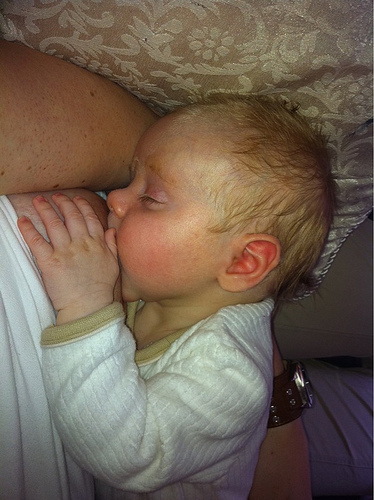<image>
Is there a baby on the chest? Yes. Looking at the image, I can see the baby is positioned on top of the chest, with the chest providing support. 